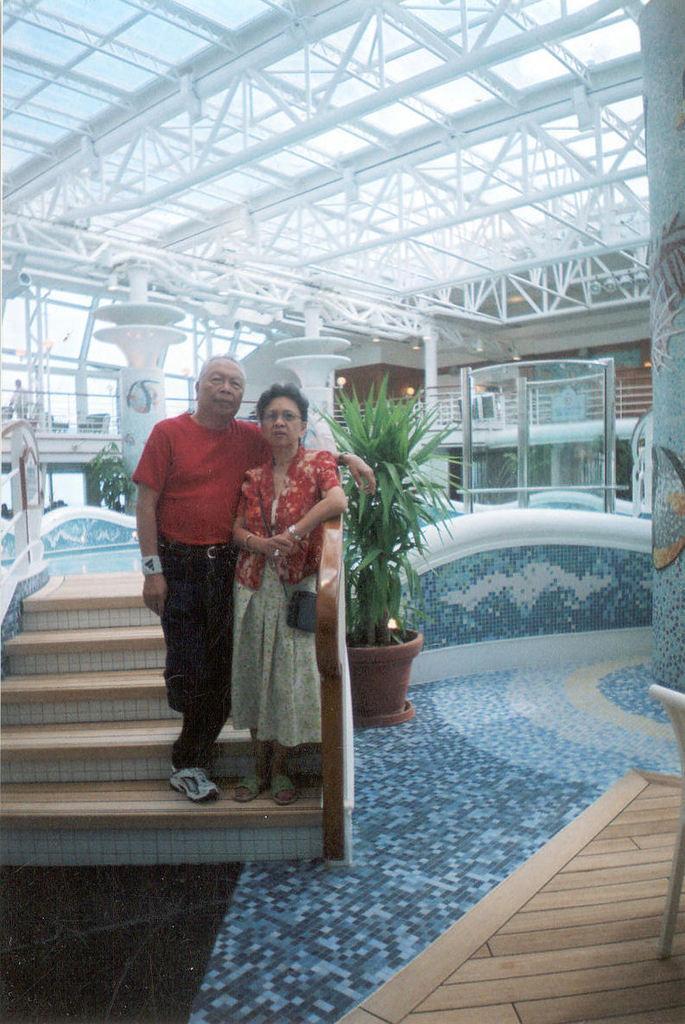Please provide a concise description of this image. In this picture there is a man and woman in the center of the image on the stairs and there is a plan pot in the image and there is a roof at the top side of the image. 